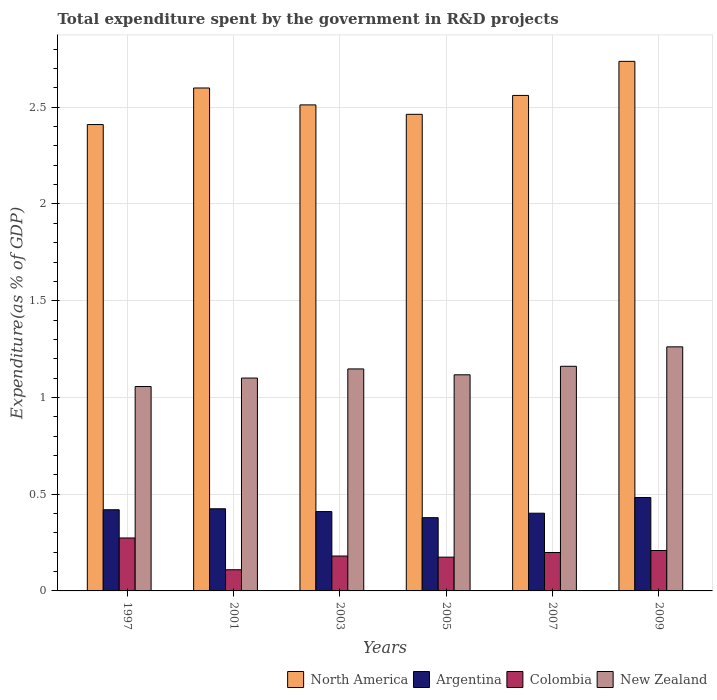How many groups of bars are there?
Offer a very short reply. 6. What is the total expenditure spent by the government in R&D projects in Argentina in 2007?
Ensure brevity in your answer.  0.4. Across all years, what is the maximum total expenditure spent by the government in R&D projects in North America?
Your answer should be compact. 2.74. Across all years, what is the minimum total expenditure spent by the government in R&D projects in Argentina?
Your answer should be very brief. 0.38. What is the total total expenditure spent by the government in R&D projects in New Zealand in the graph?
Your response must be concise. 6.84. What is the difference between the total expenditure spent by the government in R&D projects in New Zealand in 2005 and that in 2009?
Ensure brevity in your answer.  -0.14. What is the difference between the total expenditure spent by the government in R&D projects in Colombia in 2007 and the total expenditure spent by the government in R&D projects in North America in 2001?
Give a very brief answer. -2.4. What is the average total expenditure spent by the government in R&D projects in North America per year?
Make the answer very short. 2.55. In the year 2005, what is the difference between the total expenditure spent by the government in R&D projects in Argentina and total expenditure spent by the government in R&D projects in New Zealand?
Ensure brevity in your answer.  -0.74. What is the ratio of the total expenditure spent by the government in R&D projects in Colombia in 1997 to that in 2003?
Ensure brevity in your answer.  1.52. Is the difference between the total expenditure spent by the government in R&D projects in Argentina in 2005 and 2009 greater than the difference between the total expenditure spent by the government in R&D projects in New Zealand in 2005 and 2009?
Provide a succinct answer. Yes. What is the difference between the highest and the second highest total expenditure spent by the government in R&D projects in Argentina?
Offer a very short reply. 0.06. What is the difference between the highest and the lowest total expenditure spent by the government in R&D projects in North America?
Offer a very short reply. 0.33. In how many years, is the total expenditure spent by the government in R&D projects in New Zealand greater than the average total expenditure spent by the government in R&D projects in New Zealand taken over all years?
Keep it short and to the point. 3. What does the 4th bar from the left in 1997 represents?
Keep it short and to the point. New Zealand. Are all the bars in the graph horizontal?
Provide a succinct answer. No. What is the difference between two consecutive major ticks on the Y-axis?
Make the answer very short. 0.5. Are the values on the major ticks of Y-axis written in scientific E-notation?
Provide a short and direct response. No. Where does the legend appear in the graph?
Give a very brief answer. Bottom right. What is the title of the graph?
Your answer should be compact. Total expenditure spent by the government in R&D projects. What is the label or title of the X-axis?
Give a very brief answer. Years. What is the label or title of the Y-axis?
Your answer should be very brief. Expenditure(as % of GDP). What is the Expenditure(as % of GDP) in North America in 1997?
Your answer should be compact. 2.41. What is the Expenditure(as % of GDP) of Argentina in 1997?
Your answer should be compact. 0.42. What is the Expenditure(as % of GDP) in Colombia in 1997?
Your response must be concise. 0.27. What is the Expenditure(as % of GDP) of New Zealand in 1997?
Your response must be concise. 1.06. What is the Expenditure(as % of GDP) of North America in 2001?
Offer a very short reply. 2.6. What is the Expenditure(as % of GDP) in Argentina in 2001?
Your answer should be very brief. 0.42. What is the Expenditure(as % of GDP) in Colombia in 2001?
Your answer should be very brief. 0.11. What is the Expenditure(as % of GDP) in New Zealand in 2001?
Your answer should be compact. 1.1. What is the Expenditure(as % of GDP) of North America in 2003?
Your answer should be compact. 2.51. What is the Expenditure(as % of GDP) of Argentina in 2003?
Give a very brief answer. 0.41. What is the Expenditure(as % of GDP) in Colombia in 2003?
Your answer should be compact. 0.18. What is the Expenditure(as % of GDP) in New Zealand in 2003?
Your response must be concise. 1.15. What is the Expenditure(as % of GDP) of North America in 2005?
Provide a short and direct response. 2.46. What is the Expenditure(as % of GDP) in Argentina in 2005?
Your answer should be very brief. 0.38. What is the Expenditure(as % of GDP) in Colombia in 2005?
Offer a terse response. 0.17. What is the Expenditure(as % of GDP) of New Zealand in 2005?
Your answer should be compact. 1.12. What is the Expenditure(as % of GDP) of North America in 2007?
Give a very brief answer. 2.56. What is the Expenditure(as % of GDP) in Argentina in 2007?
Ensure brevity in your answer.  0.4. What is the Expenditure(as % of GDP) of Colombia in 2007?
Your answer should be compact. 0.2. What is the Expenditure(as % of GDP) in New Zealand in 2007?
Keep it short and to the point. 1.16. What is the Expenditure(as % of GDP) in North America in 2009?
Keep it short and to the point. 2.74. What is the Expenditure(as % of GDP) of Argentina in 2009?
Provide a short and direct response. 0.48. What is the Expenditure(as % of GDP) in Colombia in 2009?
Your answer should be compact. 0.21. What is the Expenditure(as % of GDP) of New Zealand in 2009?
Give a very brief answer. 1.26. Across all years, what is the maximum Expenditure(as % of GDP) of North America?
Provide a succinct answer. 2.74. Across all years, what is the maximum Expenditure(as % of GDP) in Argentina?
Provide a short and direct response. 0.48. Across all years, what is the maximum Expenditure(as % of GDP) in Colombia?
Give a very brief answer. 0.27. Across all years, what is the maximum Expenditure(as % of GDP) of New Zealand?
Make the answer very short. 1.26. Across all years, what is the minimum Expenditure(as % of GDP) of North America?
Your answer should be very brief. 2.41. Across all years, what is the minimum Expenditure(as % of GDP) of Argentina?
Keep it short and to the point. 0.38. Across all years, what is the minimum Expenditure(as % of GDP) in Colombia?
Your answer should be compact. 0.11. Across all years, what is the minimum Expenditure(as % of GDP) of New Zealand?
Offer a very short reply. 1.06. What is the total Expenditure(as % of GDP) of North America in the graph?
Keep it short and to the point. 15.28. What is the total Expenditure(as % of GDP) of Argentina in the graph?
Give a very brief answer. 2.52. What is the total Expenditure(as % of GDP) in Colombia in the graph?
Offer a terse response. 1.15. What is the total Expenditure(as % of GDP) in New Zealand in the graph?
Your answer should be compact. 6.84. What is the difference between the Expenditure(as % of GDP) of North America in 1997 and that in 2001?
Your answer should be very brief. -0.19. What is the difference between the Expenditure(as % of GDP) of Argentina in 1997 and that in 2001?
Make the answer very short. -0.01. What is the difference between the Expenditure(as % of GDP) of Colombia in 1997 and that in 2001?
Your answer should be very brief. 0.16. What is the difference between the Expenditure(as % of GDP) of New Zealand in 1997 and that in 2001?
Offer a terse response. -0.04. What is the difference between the Expenditure(as % of GDP) of North America in 1997 and that in 2003?
Your response must be concise. -0.1. What is the difference between the Expenditure(as % of GDP) in Argentina in 1997 and that in 2003?
Offer a very short reply. 0.01. What is the difference between the Expenditure(as % of GDP) in Colombia in 1997 and that in 2003?
Ensure brevity in your answer.  0.09. What is the difference between the Expenditure(as % of GDP) in New Zealand in 1997 and that in 2003?
Give a very brief answer. -0.09. What is the difference between the Expenditure(as % of GDP) in North America in 1997 and that in 2005?
Offer a very short reply. -0.05. What is the difference between the Expenditure(as % of GDP) in Argentina in 1997 and that in 2005?
Make the answer very short. 0.04. What is the difference between the Expenditure(as % of GDP) of Colombia in 1997 and that in 2005?
Your response must be concise. 0.1. What is the difference between the Expenditure(as % of GDP) in New Zealand in 1997 and that in 2005?
Offer a terse response. -0.06. What is the difference between the Expenditure(as % of GDP) of North America in 1997 and that in 2007?
Your response must be concise. -0.15. What is the difference between the Expenditure(as % of GDP) in Argentina in 1997 and that in 2007?
Your answer should be very brief. 0.02. What is the difference between the Expenditure(as % of GDP) in Colombia in 1997 and that in 2007?
Provide a succinct answer. 0.08. What is the difference between the Expenditure(as % of GDP) of New Zealand in 1997 and that in 2007?
Ensure brevity in your answer.  -0.1. What is the difference between the Expenditure(as % of GDP) of North America in 1997 and that in 2009?
Provide a short and direct response. -0.33. What is the difference between the Expenditure(as % of GDP) in Argentina in 1997 and that in 2009?
Offer a terse response. -0.06. What is the difference between the Expenditure(as % of GDP) of Colombia in 1997 and that in 2009?
Offer a terse response. 0.06. What is the difference between the Expenditure(as % of GDP) of New Zealand in 1997 and that in 2009?
Provide a succinct answer. -0.21. What is the difference between the Expenditure(as % of GDP) in North America in 2001 and that in 2003?
Ensure brevity in your answer.  0.09. What is the difference between the Expenditure(as % of GDP) in Argentina in 2001 and that in 2003?
Keep it short and to the point. 0.01. What is the difference between the Expenditure(as % of GDP) in Colombia in 2001 and that in 2003?
Offer a terse response. -0.07. What is the difference between the Expenditure(as % of GDP) in New Zealand in 2001 and that in 2003?
Ensure brevity in your answer.  -0.05. What is the difference between the Expenditure(as % of GDP) in North America in 2001 and that in 2005?
Offer a very short reply. 0.14. What is the difference between the Expenditure(as % of GDP) in Argentina in 2001 and that in 2005?
Keep it short and to the point. 0.05. What is the difference between the Expenditure(as % of GDP) of Colombia in 2001 and that in 2005?
Your answer should be very brief. -0.07. What is the difference between the Expenditure(as % of GDP) of New Zealand in 2001 and that in 2005?
Offer a terse response. -0.02. What is the difference between the Expenditure(as % of GDP) of North America in 2001 and that in 2007?
Make the answer very short. 0.04. What is the difference between the Expenditure(as % of GDP) in Argentina in 2001 and that in 2007?
Ensure brevity in your answer.  0.02. What is the difference between the Expenditure(as % of GDP) of Colombia in 2001 and that in 2007?
Offer a terse response. -0.09. What is the difference between the Expenditure(as % of GDP) of New Zealand in 2001 and that in 2007?
Offer a terse response. -0.06. What is the difference between the Expenditure(as % of GDP) in North America in 2001 and that in 2009?
Make the answer very short. -0.14. What is the difference between the Expenditure(as % of GDP) of Argentina in 2001 and that in 2009?
Make the answer very short. -0.06. What is the difference between the Expenditure(as % of GDP) in Colombia in 2001 and that in 2009?
Your response must be concise. -0.1. What is the difference between the Expenditure(as % of GDP) in New Zealand in 2001 and that in 2009?
Offer a terse response. -0.16. What is the difference between the Expenditure(as % of GDP) in North America in 2003 and that in 2005?
Provide a succinct answer. 0.05. What is the difference between the Expenditure(as % of GDP) of Argentina in 2003 and that in 2005?
Make the answer very short. 0.03. What is the difference between the Expenditure(as % of GDP) of Colombia in 2003 and that in 2005?
Give a very brief answer. 0.01. What is the difference between the Expenditure(as % of GDP) of New Zealand in 2003 and that in 2005?
Provide a succinct answer. 0.03. What is the difference between the Expenditure(as % of GDP) in North America in 2003 and that in 2007?
Provide a succinct answer. -0.05. What is the difference between the Expenditure(as % of GDP) in Argentina in 2003 and that in 2007?
Your answer should be compact. 0.01. What is the difference between the Expenditure(as % of GDP) of Colombia in 2003 and that in 2007?
Ensure brevity in your answer.  -0.02. What is the difference between the Expenditure(as % of GDP) in New Zealand in 2003 and that in 2007?
Provide a succinct answer. -0.01. What is the difference between the Expenditure(as % of GDP) in North America in 2003 and that in 2009?
Your response must be concise. -0.23. What is the difference between the Expenditure(as % of GDP) of Argentina in 2003 and that in 2009?
Offer a terse response. -0.07. What is the difference between the Expenditure(as % of GDP) of Colombia in 2003 and that in 2009?
Your response must be concise. -0.03. What is the difference between the Expenditure(as % of GDP) in New Zealand in 2003 and that in 2009?
Provide a short and direct response. -0.11. What is the difference between the Expenditure(as % of GDP) in North America in 2005 and that in 2007?
Your response must be concise. -0.1. What is the difference between the Expenditure(as % of GDP) of Argentina in 2005 and that in 2007?
Your answer should be compact. -0.02. What is the difference between the Expenditure(as % of GDP) in Colombia in 2005 and that in 2007?
Your answer should be very brief. -0.02. What is the difference between the Expenditure(as % of GDP) in New Zealand in 2005 and that in 2007?
Make the answer very short. -0.04. What is the difference between the Expenditure(as % of GDP) in North America in 2005 and that in 2009?
Offer a terse response. -0.27. What is the difference between the Expenditure(as % of GDP) of Argentina in 2005 and that in 2009?
Ensure brevity in your answer.  -0.1. What is the difference between the Expenditure(as % of GDP) in Colombia in 2005 and that in 2009?
Ensure brevity in your answer.  -0.03. What is the difference between the Expenditure(as % of GDP) of New Zealand in 2005 and that in 2009?
Your answer should be very brief. -0.14. What is the difference between the Expenditure(as % of GDP) in North America in 2007 and that in 2009?
Offer a very short reply. -0.18. What is the difference between the Expenditure(as % of GDP) in Argentina in 2007 and that in 2009?
Offer a very short reply. -0.08. What is the difference between the Expenditure(as % of GDP) in Colombia in 2007 and that in 2009?
Make the answer very short. -0.01. What is the difference between the Expenditure(as % of GDP) in New Zealand in 2007 and that in 2009?
Keep it short and to the point. -0.1. What is the difference between the Expenditure(as % of GDP) in North America in 1997 and the Expenditure(as % of GDP) in Argentina in 2001?
Offer a terse response. 1.99. What is the difference between the Expenditure(as % of GDP) of North America in 1997 and the Expenditure(as % of GDP) of Colombia in 2001?
Make the answer very short. 2.3. What is the difference between the Expenditure(as % of GDP) of North America in 1997 and the Expenditure(as % of GDP) of New Zealand in 2001?
Ensure brevity in your answer.  1.31. What is the difference between the Expenditure(as % of GDP) of Argentina in 1997 and the Expenditure(as % of GDP) of Colombia in 2001?
Keep it short and to the point. 0.31. What is the difference between the Expenditure(as % of GDP) in Argentina in 1997 and the Expenditure(as % of GDP) in New Zealand in 2001?
Provide a succinct answer. -0.68. What is the difference between the Expenditure(as % of GDP) of Colombia in 1997 and the Expenditure(as % of GDP) of New Zealand in 2001?
Your response must be concise. -0.83. What is the difference between the Expenditure(as % of GDP) in North America in 1997 and the Expenditure(as % of GDP) in Argentina in 2003?
Offer a terse response. 2. What is the difference between the Expenditure(as % of GDP) of North America in 1997 and the Expenditure(as % of GDP) of Colombia in 2003?
Offer a terse response. 2.23. What is the difference between the Expenditure(as % of GDP) in North America in 1997 and the Expenditure(as % of GDP) in New Zealand in 2003?
Give a very brief answer. 1.26. What is the difference between the Expenditure(as % of GDP) of Argentina in 1997 and the Expenditure(as % of GDP) of Colombia in 2003?
Give a very brief answer. 0.24. What is the difference between the Expenditure(as % of GDP) of Argentina in 1997 and the Expenditure(as % of GDP) of New Zealand in 2003?
Offer a very short reply. -0.73. What is the difference between the Expenditure(as % of GDP) in Colombia in 1997 and the Expenditure(as % of GDP) in New Zealand in 2003?
Provide a short and direct response. -0.87. What is the difference between the Expenditure(as % of GDP) in North America in 1997 and the Expenditure(as % of GDP) in Argentina in 2005?
Ensure brevity in your answer.  2.03. What is the difference between the Expenditure(as % of GDP) of North America in 1997 and the Expenditure(as % of GDP) of Colombia in 2005?
Offer a very short reply. 2.24. What is the difference between the Expenditure(as % of GDP) in North America in 1997 and the Expenditure(as % of GDP) in New Zealand in 2005?
Your answer should be compact. 1.29. What is the difference between the Expenditure(as % of GDP) of Argentina in 1997 and the Expenditure(as % of GDP) of Colombia in 2005?
Keep it short and to the point. 0.24. What is the difference between the Expenditure(as % of GDP) of Argentina in 1997 and the Expenditure(as % of GDP) of New Zealand in 2005?
Make the answer very short. -0.7. What is the difference between the Expenditure(as % of GDP) of Colombia in 1997 and the Expenditure(as % of GDP) of New Zealand in 2005?
Offer a very short reply. -0.84. What is the difference between the Expenditure(as % of GDP) in North America in 1997 and the Expenditure(as % of GDP) in Argentina in 2007?
Keep it short and to the point. 2.01. What is the difference between the Expenditure(as % of GDP) of North America in 1997 and the Expenditure(as % of GDP) of Colombia in 2007?
Offer a very short reply. 2.21. What is the difference between the Expenditure(as % of GDP) in North America in 1997 and the Expenditure(as % of GDP) in New Zealand in 2007?
Your response must be concise. 1.25. What is the difference between the Expenditure(as % of GDP) in Argentina in 1997 and the Expenditure(as % of GDP) in Colombia in 2007?
Keep it short and to the point. 0.22. What is the difference between the Expenditure(as % of GDP) in Argentina in 1997 and the Expenditure(as % of GDP) in New Zealand in 2007?
Make the answer very short. -0.74. What is the difference between the Expenditure(as % of GDP) of Colombia in 1997 and the Expenditure(as % of GDP) of New Zealand in 2007?
Your answer should be very brief. -0.89. What is the difference between the Expenditure(as % of GDP) of North America in 1997 and the Expenditure(as % of GDP) of Argentina in 2009?
Keep it short and to the point. 1.93. What is the difference between the Expenditure(as % of GDP) in North America in 1997 and the Expenditure(as % of GDP) in Colombia in 2009?
Make the answer very short. 2.2. What is the difference between the Expenditure(as % of GDP) in North America in 1997 and the Expenditure(as % of GDP) in New Zealand in 2009?
Keep it short and to the point. 1.15. What is the difference between the Expenditure(as % of GDP) of Argentina in 1997 and the Expenditure(as % of GDP) of Colombia in 2009?
Your answer should be compact. 0.21. What is the difference between the Expenditure(as % of GDP) of Argentina in 1997 and the Expenditure(as % of GDP) of New Zealand in 2009?
Provide a succinct answer. -0.84. What is the difference between the Expenditure(as % of GDP) of Colombia in 1997 and the Expenditure(as % of GDP) of New Zealand in 2009?
Offer a very short reply. -0.99. What is the difference between the Expenditure(as % of GDP) of North America in 2001 and the Expenditure(as % of GDP) of Argentina in 2003?
Give a very brief answer. 2.19. What is the difference between the Expenditure(as % of GDP) in North America in 2001 and the Expenditure(as % of GDP) in Colombia in 2003?
Keep it short and to the point. 2.42. What is the difference between the Expenditure(as % of GDP) in North America in 2001 and the Expenditure(as % of GDP) in New Zealand in 2003?
Keep it short and to the point. 1.45. What is the difference between the Expenditure(as % of GDP) in Argentina in 2001 and the Expenditure(as % of GDP) in Colombia in 2003?
Make the answer very short. 0.24. What is the difference between the Expenditure(as % of GDP) in Argentina in 2001 and the Expenditure(as % of GDP) in New Zealand in 2003?
Give a very brief answer. -0.72. What is the difference between the Expenditure(as % of GDP) of Colombia in 2001 and the Expenditure(as % of GDP) of New Zealand in 2003?
Offer a very short reply. -1.04. What is the difference between the Expenditure(as % of GDP) of North America in 2001 and the Expenditure(as % of GDP) of Argentina in 2005?
Keep it short and to the point. 2.22. What is the difference between the Expenditure(as % of GDP) in North America in 2001 and the Expenditure(as % of GDP) in Colombia in 2005?
Offer a terse response. 2.43. What is the difference between the Expenditure(as % of GDP) in North America in 2001 and the Expenditure(as % of GDP) in New Zealand in 2005?
Your answer should be very brief. 1.48. What is the difference between the Expenditure(as % of GDP) of Argentina in 2001 and the Expenditure(as % of GDP) of Colombia in 2005?
Provide a succinct answer. 0.25. What is the difference between the Expenditure(as % of GDP) of Argentina in 2001 and the Expenditure(as % of GDP) of New Zealand in 2005?
Your answer should be compact. -0.69. What is the difference between the Expenditure(as % of GDP) in Colombia in 2001 and the Expenditure(as % of GDP) in New Zealand in 2005?
Give a very brief answer. -1.01. What is the difference between the Expenditure(as % of GDP) of North America in 2001 and the Expenditure(as % of GDP) of Argentina in 2007?
Ensure brevity in your answer.  2.2. What is the difference between the Expenditure(as % of GDP) of North America in 2001 and the Expenditure(as % of GDP) of Colombia in 2007?
Give a very brief answer. 2.4. What is the difference between the Expenditure(as % of GDP) in North America in 2001 and the Expenditure(as % of GDP) in New Zealand in 2007?
Your answer should be very brief. 1.44. What is the difference between the Expenditure(as % of GDP) in Argentina in 2001 and the Expenditure(as % of GDP) in Colombia in 2007?
Ensure brevity in your answer.  0.23. What is the difference between the Expenditure(as % of GDP) in Argentina in 2001 and the Expenditure(as % of GDP) in New Zealand in 2007?
Give a very brief answer. -0.74. What is the difference between the Expenditure(as % of GDP) of Colombia in 2001 and the Expenditure(as % of GDP) of New Zealand in 2007?
Ensure brevity in your answer.  -1.05. What is the difference between the Expenditure(as % of GDP) in North America in 2001 and the Expenditure(as % of GDP) in Argentina in 2009?
Your answer should be very brief. 2.12. What is the difference between the Expenditure(as % of GDP) in North America in 2001 and the Expenditure(as % of GDP) in Colombia in 2009?
Keep it short and to the point. 2.39. What is the difference between the Expenditure(as % of GDP) in North America in 2001 and the Expenditure(as % of GDP) in New Zealand in 2009?
Your answer should be compact. 1.34. What is the difference between the Expenditure(as % of GDP) in Argentina in 2001 and the Expenditure(as % of GDP) in Colombia in 2009?
Give a very brief answer. 0.22. What is the difference between the Expenditure(as % of GDP) of Argentina in 2001 and the Expenditure(as % of GDP) of New Zealand in 2009?
Your answer should be very brief. -0.84. What is the difference between the Expenditure(as % of GDP) in Colombia in 2001 and the Expenditure(as % of GDP) in New Zealand in 2009?
Provide a short and direct response. -1.15. What is the difference between the Expenditure(as % of GDP) in North America in 2003 and the Expenditure(as % of GDP) in Argentina in 2005?
Your response must be concise. 2.13. What is the difference between the Expenditure(as % of GDP) of North America in 2003 and the Expenditure(as % of GDP) of Colombia in 2005?
Your response must be concise. 2.34. What is the difference between the Expenditure(as % of GDP) in North America in 2003 and the Expenditure(as % of GDP) in New Zealand in 2005?
Offer a terse response. 1.4. What is the difference between the Expenditure(as % of GDP) of Argentina in 2003 and the Expenditure(as % of GDP) of Colombia in 2005?
Your response must be concise. 0.24. What is the difference between the Expenditure(as % of GDP) of Argentina in 2003 and the Expenditure(as % of GDP) of New Zealand in 2005?
Make the answer very short. -0.71. What is the difference between the Expenditure(as % of GDP) in Colombia in 2003 and the Expenditure(as % of GDP) in New Zealand in 2005?
Provide a succinct answer. -0.94. What is the difference between the Expenditure(as % of GDP) of North America in 2003 and the Expenditure(as % of GDP) of Argentina in 2007?
Your response must be concise. 2.11. What is the difference between the Expenditure(as % of GDP) in North America in 2003 and the Expenditure(as % of GDP) in Colombia in 2007?
Ensure brevity in your answer.  2.31. What is the difference between the Expenditure(as % of GDP) of North America in 2003 and the Expenditure(as % of GDP) of New Zealand in 2007?
Keep it short and to the point. 1.35. What is the difference between the Expenditure(as % of GDP) of Argentina in 2003 and the Expenditure(as % of GDP) of Colombia in 2007?
Ensure brevity in your answer.  0.21. What is the difference between the Expenditure(as % of GDP) of Argentina in 2003 and the Expenditure(as % of GDP) of New Zealand in 2007?
Your response must be concise. -0.75. What is the difference between the Expenditure(as % of GDP) in Colombia in 2003 and the Expenditure(as % of GDP) in New Zealand in 2007?
Your answer should be very brief. -0.98. What is the difference between the Expenditure(as % of GDP) in North America in 2003 and the Expenditure(as % of GDP) in Argentina in 2009?
Your answer should be very brief. 2.03. What is the difference between the Expenditure(as % of GDP) of North America in 2003 and the Expenditure(as % of GDP) of Colombia in 2009?
Your answer should be compact. 2.3. What is the difference between the Expenditure(as % of GDP) in North America in 2003 and the Expenditure(as % of GDP) in New Zealand in 2009?
Your answer should be compact. 1.25. What is the difference between the Expenditure(as % of GDP) of Argentina in 2003 and the Expenditure(as % of GDP) of Colombia in 2009?
Your response must be concise. 0.2. What is the difference between the Expenditure(as % of GDP) in Argentina in 2003 and the Expenditure(as % of GDP) in New Zealand in 2009?
Make the answer very short. -0.85. What is the difference between the Expenditure(as % of GDP) of Colombia in 2003 and the Expenditure(as % of GDP) of New Zealand in 2009?
Provide a succinct answer. -1.08. What is the difference between the Expenditure(as % of GDP) in North America in 2005 and the Expenditure(as % of GDP) in Argentina in 2007?
Your answer should be very brief. 2.06. What is the difference between the Expenditure(as % of GDP) of North America in 2005 and the Expenditure(as % of GDP) of Colombia in 2007?
Provide a short and direct response. 2.27. What is the difference between the Expenditure(as % of GDP) in North America in 2005 and the Expenditure(as % of GDP) in New Zealand in 2007?
Your answer should be compact. 1.3. What is the difference between the Expenditure(as % of GDP) of Argentina in 2005 and the Expenditure(as % of GDP) of Colombia in 2007?
Offer a terse response. 0.18. What is the difference between the Expenditure(as % of GDP) of Argentina in 2005 and the Expenditure(as % of GDP) of New Zealand in 2007?
Offer a terse response. -0.78. What is the difference between the Expenditure(as % of GDP) of Colombia in 2005 and the Expenditure(as % of GDP) of New Zealand in 2007?
Keep it short and to the point. -0.99. What is the difference between the Expenditure(as % of GDP) in North America in 2005 and the Expenditure(as % of GDP) in Argentina in 2009?
Keep it short and to the point. 1.98. What is the difference between the Expenditure(as % of GDP) of North America in 2005 and the Expenditure(as % of GDP) of Colombia in 2009?
Offer a very short reply. 2.25. What is the difference between the Expenditure(as % of GDP) in North America in 2005 and the Expenditure(as % of GDP) in New Zealand in 2009?
Offer a terse response. 1.2. What is the difference between the Expenditure(as % of GDP) of Argentina in 2005 and the Expenditure(as % of GDP) of Colombia in 2009?
Your response must be concise. 0.17. What is the difference between the Expenditure(as % of GDP) of Argentina in 2005 and the Expenditure(as % of GDP) of New Zealand in 2009?
Your answer should be very brief. -0.88. What is the difference between the Expenditure(as % of GDP) in Colombia in 2005 and the Expenditure(as % of GDP) in New Zealand in 2009?
Ensure brevity in your answer.  -1.09. What is the difference between the Expenditure(as % of GDP) in North America in 2007 and the Expenditure(as % of GDP) in Argentina in 2009?
Your answer should be very brief. 2.08. What is the difference between the Expenditure(as % of GDP) in North America in 2007 and the Expenditure(as % of GDP) in Colombia in 2009?
Ensure brevity in your answer.  2.35. What is the difference between the Expenditure(as % of GDP) of North America in 2007 and the Expenditure(as % of GDP) of New Zealand in 2009?
Offer a very short reply. 1.3. What is the difference between the Expenditure(as % of GDP) of Argentina in 2007 and the Expenditure(as % of GDP) of Colombia in 2009?
Give a very brief answer. 0.19. What is the difference between the Expenditure(as % of GDP) in Argentina in 2007 and the Expenditure(as % of GDP) in New Zealand in 2009?
Provide a short and direct response. -0.86. What is the difference between the Expenditure(as % of GDP) of Colombia in 2007 and the Expenditure(as % of GDP) of New Zealand in 2009?
Your answer should be compact. -1.06. What is the average Expenditure(as % of GDP) in North America per year?
Offer a terse response. 2.55. What is the average Expenditure(as % of GDP) in Argentina per year?
Your answer should be very brief. 0.42. What is the average Expenditure(as % of GDP) in Colombia per year?
Ensure brevity in your answer.  0.19. What is the average Expenditure(as % of GDP) of New Zealand per year?
Make the answer very short. 1.14. In the year 1997, what is the difference between the Expenditure(as % of GDP) in North America and Expenditure(as % of GDP) in Argentina?
Your answer should be very brief. 1.99. In the year 1997, what is the difference between the Expenditure(as % of GDP) of North America and Expenditure(as % of GDP) of Colombia?
Your answer should be very brief. 2.14. In the year 1997, what is the difference between the Expenditure(as % of GDP) in North America and Expenditure(as % of GDP) in New Zealand?
Provide a short and direct response. 1.35. In the year 1997, what is the difference between the Expenditure(as % of GDP) of Argentina and Expenditure(as % of GDP) of Colombia?
Provide a succinct answer. 0.15. In the year 1997, what is the difference between the Expenditure(as % of GDP) in Argentina and Expenditure(as % of GDP) in New Zealand?
Give a very brief answer. -0.64. In the year 1997, what is the difference between the Expenditure(as % of GDP) in Colombia and Expenditure(as % of GDP) in New Zealand?
Make the answer very short. -0.78. In the year 2001, what is the difference between the Expenditure(as % of GDP) in North America and Expenditure(as % of GDP) in Argentina?
Give a very brief answer. 2.17. In the year 2001, what is the difference between the Expenditure(as % of GDP) in North America and Expenditure(as % of GDP) in Colombia?
Offer a terse response. 2.49. In the year 2001, what is the difference between the Expenditure(as % of GDP) in North America and Expenditure(as % of GDP) in New Zealand?
Provide a short and direct response. 1.5. In the year 2001, what is the difference between the Expenditure(as % of GDP) in Argentina and Expenditure(as % of GDP) in Colombia?
Provide a succinct answer. 0.32. In the year 2001, what is the difference between the Expenditure(as % of GDP) in Argentina and Expenditure(as % of GDP) in New Zealand?
Make the answer very short. -0.68. In the year 2001, what is the difference between the Expenditure(as % of GDP) of Colombia and Expenditure(as % of GDP) of New Zealand?
Make the answer very short. -0.99. In the year 2003, what is the difference between the Expenditure(as % of GDP) in North America and Expenditure(as % of GDP) in Argentina?
Provide a short and direct response. 2.1. In the year 2003, what is the difference between the Expenditure(as % of GDP) of North America and Expenditure(as % of GDP) of Colombia?
Give a very brief answer. 2.33. In the year 2003, what is the difference between the Expenditure(as % of GDP) of North America and Expenditure(as % of GDP) of New Zealand?
Your answer should be very brief. 1.36. In the year 2003, what is the difference between the Expenditure(as % of GDP) in Argentina and Expenditure(as % of GDP) in Colombia?
Give a very brief answer. 0.23. In the year 2003, what is the difference between the Expenditure(as % of GDP) of Argentina and Expenditure(as % of GDP) of New Zealand?
Keep it short and to the point. -0.74. In the year 2003, what is the difference between the Expenditure(as % of GDP) in Colombia and Expenditure(as % of GDP) in New Zealand?
Ensure brevity in your answer.  -0.97. In the year 2005, what is the difference between the Expenditure(as % of GDP) of North America and Expenditure(as % of GDP) of Argentina?
Your response must be concise. 2.08. In the year 2005, what is the difference between the Expenditure(as % of GDP) of North America and Expenditure(as % of GDP) of Colombia?
Provide a short and direct response. 2.29. In the year 2005, what is the difference between the Expenditure(as % of GDP) of North America and Expenditure(as % of GDP) of New Zealand?
Provide a short and direct response. 1.35. In the year 2005, what is the difference between the Expenditure(as % of GDP) in Argentina and Expenditure(as % of GDP) in Colombia?
Offer a terse response. 0.2. In the year 2005, what is the difference between the Expenditure(as % of GDP) in Argentina and Expenditure(as % of GDP) in New Zealand?
Offer a terse response. -0.74. In the year 2005, what is the difference between the Expenditure(as % of GDP) in Colombia and Expenditure(as % of GDP) in New Zealand?
Ensure brevity in your answer.  -0.94. In the year 2007, what is the difference between the Expenditure(as % of GDP) of North America and Expenditure(as % of GDP) of Argentina?
Keep it short and to the point. 2.16. In the year 2007, what is the difference between the Expenditure(as % of GDP) of North America and Expenditure(as % of GDP) of Colombia?
Give a very brief answer. 2.36. In the year 2007, what is the difference between the Expenditure(as % of GDP) in North America and Expenditure(as % of GDP) in New Zealand?
Make the answer very short. 1.4. In the year 2007, what is the difference between the Expenditure(as % of GDP) of Argentina and Expenditure(as % of GDP) of Colombia?
Ensure brevity in your answer.  0.2. In the year 2007, what is the difference between the Expenditure(as % of GDP) of Argentina and Expenditure(as % of GDP) of New Zealand?
Give a very brief answer. -0.76. In the year 2007, what is the difference between the Expenditure(as % of GDP) in Colombia and Expenditure(as % of GDP) in New Zealand?
Your answer should be compact. -0.96. In the year 2009, what is the difference between the Expenditure(as % of GDP) in North America and Expenditure(as % of GDP) in Argentina?
Ensure brevity in your answer.  2.25. In the year 2009, what is the difference between the Expenditure(as % of GDP) of North America and Expenditure(as % of GDP) of Colombia?
Provide a short and direct response. 2.53. In the year 2009, what is the difference between the Expenditure(as % of GDP) in North America and Expenditure(as % of GDP) in New Zealand?
Keep it short and to the point. 1.48. In the year 2009, what is the difference between the Expenditure(as % of GDP) in Argentina and Expenditure(as % of GDP) in Colombia?
Provide a succinct answer. 0.27. In the year 2009, what is the difference between the Expenditure(as % of GDP) of Argentina and Expenditure(as % of GDP) of New Zealand?
Ensure brevity in your answer.  -0.78. In the year 2009, what is the difference between the Expenditure(as % of GDP) of Colombia and Expenditure(as % of GDP) of New Zealand?
Your answer should be compact. -1.05. What is the ratio of the Expenditure(as % of GDP) of North America in 1997 to that in 2001?
Provide a succinct answer. 0.93. What is the ratio of the Expenditure(as % of GDP) in Argentina in 1997 to that in 2001?
Offer a very short reply. 0.99. What is the ratio of the Expenditure(as % of GDP) of Colombia in 1997 to that in 2001?
Provide a succinct answer. 2.5. What is the ratio of the Expenditure(as % of GDP) in New Zealand in 1997 to that in 2001?
Provide a succinct answer. 0.96. What is the ratio of the Expenditure(as % of GDP) of North America in 1997 to that in 2003?
Offer a terse response. 0.96. What is the ratio of the Expenditure(as % of GDP) in Argentina in 1997 to that in 2003?
Keep it short and to the point. 1.02. What is the ratio of the Expenditure(as % of GDP) in Colombia in 1997 to that in 2003?
Your answer should be very brief. 1.52. What is the ratio of the Expenditure(as % of GDP) of New Zealand in 1997 to that in 2003?
Make the answer very short. 0.92. What is the ratio of the Expenditure(as % of GDP) of North America in 1997 to that in 2005?
Make the answer very short. 0.98. What is the ratio of the Expenditure(as % of GDP) in Argentina in 1997 to that in 2005?
Make the answer very short. 1.11. What is the ratio of the Expenditure(as % of GDP) in Colombia in 1997 to that in 2005?
Your answer should be compact. 1.57. What is the ratio of the Expenditure(as % of GDP) in New Zealand in 1997 to that in 2005?
Your answer should be compact. 0.95. What is the ratio of the Expenditure(as % of GDP) in North America in 1997 to that in 2007?
Offer a very short reply. 0.94. What is the ratio of the Expenditure(as % of GDP) in Argentina in 1997 to that in 2007?
Make the answer very short. 1.04. What is the ratio of the Expenditure(as % of GDP) of Colombia in 1997 to that in 2007?
Offer a very short reply. 1.38. What is the ratio of the Expenditure(as % of GDP) of New Zealand in 1997 to that in 2007?
Ensure brevity in your answer.  0.91. What is the ratio of the Expenditure(as % of GDP) in North America in 1997 to that in 2009?
Offer a terse response. 0.88. What is the ratio of the Expenditure(as % of GDP) in Argentina in 1997 to that in 2009?
Make the answer very short. 0.87. What is the ratio of the Expenditure(as % of GDP) of Colombia in 1997 to that in 2009?
Offer a terse response. 1.31. What is the ratio of the Expenditure(as % of GDP) of New Zealand in 1997 to that in 2009?
Provide a short and direct response. 0.84. What is the ratio of the Expenditure(as % of GDP) of North America in 2001 to that in 2003?
Your answer should be very brief. 1.03. What is the ratio of the Expenditure(as % of GDP) of Argentina in 2001 to that in 2003?
Make the answer very short. 1.04. What is the ratio of the Expenditure(as % of GDP) of Colombia in 2001 to that in 2003?
Provide a short and direct response. 0.61. What is the ratio of the Expenditure(as % of GDP) of New Zealand in 2001 to that in 2003?
Ensure brevity in your answer.  0.96. What is the ratio of the Expenditure(as % of GDP) of North America in 2001 to that in 2005?
Offer a terse response. 1.06. What is the ratio of the Expenditure(as % of GDP) of Argentina in 2001 to that in 2005?
Provide a short and direct response. 1.12. What is the ratio of the Expenditure(as % of GDP) of Colombia in 2001 to that in 2005?
Provide a succinct answer. 0.63. What is the ratio of the Expenditure(as % of GDP) of New Zealand in 2001 to that in 2005?
Offer a terse response. 0.98. What is the ratio of the Expenditure(as % of GDP) in Argentina in 2001 to that in 2007?
Your response must be concise. 1.06. What is the ratio of the Expenditure(as % of GDP) of Colombia in 2001 to that in 2007?
Make the answer very short. 0.55. What is the ratio of the Expenditure(as % of GDP) in New Zealand in 2001 to that in 2007?
Provide a succinct answer. 0.95. What is the ratio of the Expenditure(as % of GDP) of North America in 2001 to that in 2009?
Give a very brief answer. 0.95. What is the ratio of the Expenditure(as % of GDP) in Argentina in 2001 to that in 2009?
Provide a succinct answer. 0.88. What is the ratio of the Expenditure(as % of GDP) of Colombia in 2001 to that in 2009?
Offer a terse response. 0.52. What is the ratio of the Expenditure(as % of GDP) in New Zealand in 2001 to that in 2009?
Offer a very short reply. 0.87. What is the ratio of the Expenditure(as % of GDP) in North America in 2003 to that in 2005?
Offer a very short reply. 1.02. What is the ratio of the Expenditure(as % of GDP) of Argentina in 2003 to that in 2005?
Offer a very short reply. 1.08. What is the ratio of the Expenditure(as % of GDP) in Colombia in 2003 to that in 2005?
Offer a very short reply. 1.03. What is the ratio of the Expenditure(as % of GDP) in New Zealand in 2003 to that in 2005?
Your answer should be compact. 1.03. What is the ratio of the Expenditure(as % of GDP) of North America in 2003 to that in 2007?
Keep it short and to the point. 0.98. What is the ratio of the Expenditure(as % of GDP) of Colombia in 2003 to that in 2007?
Give a very brief answer. 0.91. What is the ratio of the Expenditure(as % of GDP) in New Zealand in 2003 to that in 2007?
Ensure brevity in your answer.  0.99. What is the ratio of the Expenditure(as % of GDP) of North America in 2003 to that in 2009?
Your response must be concise. 0.92. What is the ratio of the Expenditure(as % of GDP) in Argentina in 2003 to that in 2009?
Keep it short and to the point. 0.85. What is the ratio of the Expenditure(as % of GDP) of Colombia in 2003 to that in 2009?
Give a very brief answer. 0.86. What is the ratio of the Expenditure(as % of GDP) of New Zealand in 2003 to that in 2009?
Provide a short and direct response. 0.91. What is the ratio of the Expenditure(as % of GDP) in North America in 2005 to that in 2007?
Provide a succinct answer. 0.96. What is the ratio of the Expenditure(as % of GDP) in Argentina in 2005 to that in 2007?
Offer a very short reply. 0.94. What is the ratio of the Expenditure(as % of GDP) of Colombia in 2005 to that in 2007?
Make the answer very short. 0.88. What is the ratio of the Expenditure(as % of GDP) of New Zealand in 2005 to that in 2007?
Offer a terse response. 0.96. What is the ratio of the Expenditure(as % of GDP) of Argentina in 2005 to that in 2009?
Provide a short and direct response. 0.78. What is the ratio of the Expenditure(as % of GDP) in Colombia in 2005 to that in 2009?
Keep it short and to the point. 0.84. What is the ratio of the Expenditure(as % of GDP) of New Zealand in 2005 to that in 2009?
Offer a very short reply. 0.89. What is the ratio of the Expenditure(as % of GDP) of North America in 2007 to that in 2009?
Provide a succinct answer. 0.94. What is the ratio of the Expenditure(as % of GDP) of Argentina in 2007 to that in 2009?
Provide a succinct answer. 0.83. What is the ratio of the Expenditure(as % of GDP) of Colombia in 2007 to that in 2009?
Offer a terse response. 0.95. What is the ratio of the Expenditure(as % of GDP) in New Zealand in 2007 to that in 2009?
Provide a short and direct response. 0.92. What is the difference between the highest and the second highest Expenditure(as % of GDP) of North America?
Ensure brevity in your answer.  0.14. What is the difference between the highest and the second highest Expenditure(as % of GDP) in Argentina?
Make the answer very short. 0.06. What is the difference between the highest and the second highest Expenditure(as % of GDP) in Colombia?
Provide a succinct answer. 0.06. What is the difference between the highest and the second highest Expenditure(as % of GDP) in New Zealand?
Your answer should be very brief. 0.1. What is the difference between the highest and the lowest Expenditure(as % of GDP) of North America?
Ensure brevity in your answer.  0.33. What is the difference between the highest and the lowest Expenditure(as % of GDP) of Argentina?
Offer a very short reply. 0.1. What is the difference between the highest and the lowest Expenditure(as % of GDP) in Colombia?
Your answer should be compact. 0.16. What is the difference between the highest and the lowest Expenditure(as % of GDP) of New Zealand?
Your answer should be very brief. 0.21. 